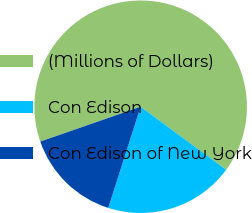<chart> <loc_0><loc_0><loc_500><loc_500><pie_chart><fcel>(Millions of Dollars)<fcel>Con Edison<fcel>Con Edison of New York<nl><fcel>65.43%<fcel>19.82%<fcel>14.75%<nl></chart> 